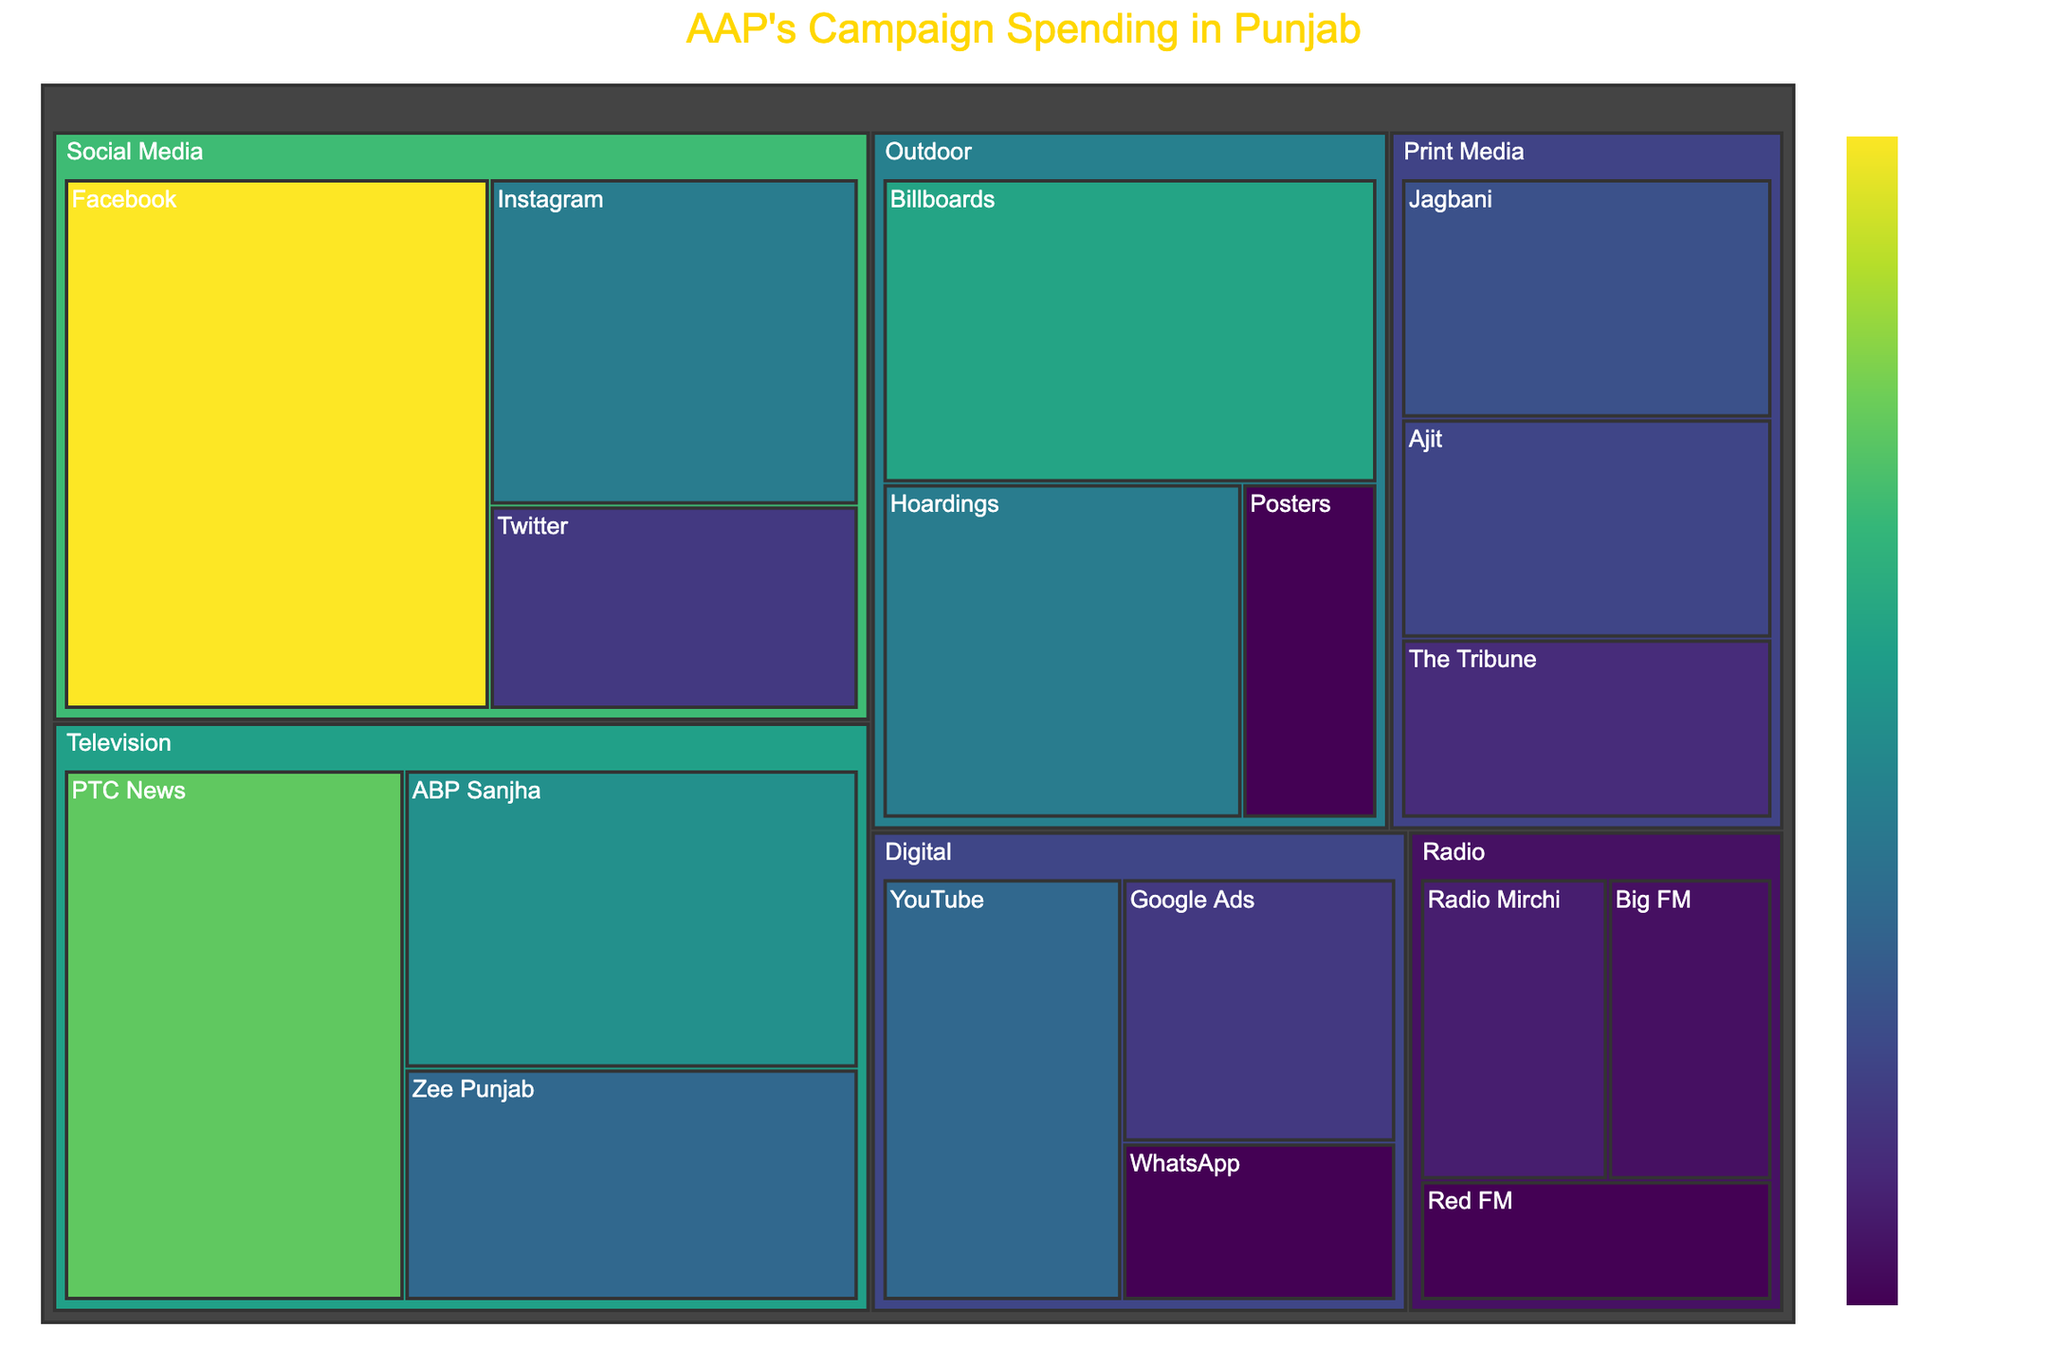What's the largest spending subchannel within the "Television" channel? To find the largest spending subchannel within "Television," look for the subchannel in the "Television" section with the highest spending value.
Answer: PTC News Which subchannel in "Social Media" received the least amount of spending? In the "Social Media" section, identify the subchannel with the smallest spending amount.
Answer: Twitter What is the total spending for the "Outdoor" channel? Add up the spending amounts for all the subchannels under the "Outdoor" channel: Billboards (₹10,000,000) + Hoardings (₹8,000,000) + Posters (₹3,000,000) = ₹21,000,000.
Answer: ₹21,000,000 How much more did "Facebook" receive compared to "Instagram"? First, see the spending for "Facebook" (₹15,000,000) and "Instagram" (₹8,000,000). Subtract Instagram's spending from Facebook's spending: ₹15,000,000 - ₹8,000,000.
Answer: ₹7,000,000 Which media channel has the highest total spending? Sum up the spending for each main channel and identify the channel with the highest total. Calculating, Social Media: ₹28,000,000, Television: ₹28,000,000, Print Media: ₹16,000,000, Outdoor: ₹21,000,000, Radio: ₹10,500,000, Digital: ₹15,000,000. Both Social Media and Television have the highest at ₹28,000,000 each.
Answer: Social Media and Television Identify the subchannel with the lowest spending across all media channels. Scan the entire treemap to find the subchannel with the smallest value.
Answer: Posters What percentage of the total "Social Media" spending went to "Instagram"? First, determine the total spending within "Social Media" which is ₹28,000,000. "Instagram" received ₹8,000,000. Calculate the percentage: (₹8,000,000 / ₹28,000,000) * 100%.
Answer: 28.57% List the spending amounts for each subchannel in the "Digital" media channel. Find all subchannels under "Digital" and their respective spending amounts: YouTube (₹7,000,000), Google Ads (₹5,000,000), WhatsApp (₹3,000,000).
Answer: YouTube: ₹7,000,000, Google Ads: ₹5,000,000, WhatsApp: ₹3,000,000 